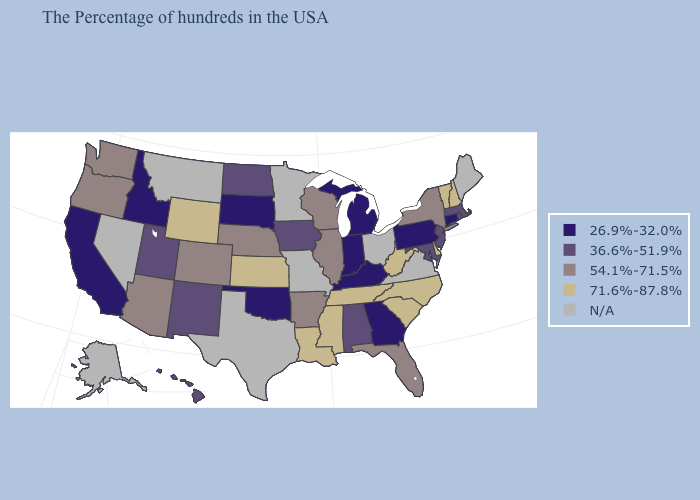What is the highest value in the MidWest ?
Give a very brief answer. 71.6%-87.8%. Which states hav the highest value in the West?
Short answer required. Wyoming. Among the states that border Georgia , which have the highest value?
Answer briefly. North Carolina, South Carolina, Tennessee. What is the lowest value in the USA?
Be succinct. 26.9%-32.0%. Which states have the lowest value in the MidWest?
Short answer required. Michigan, Indiana, South Dakota. Name the states that have a value in the range 54.1%-71.5%?
Write a very short answer. New York, Florida, Wisconsin, Illinois, Arkansas, Nebraska, Colorado, Arizona, Washington, Oregon. Name the states that have a value in the range 26.9%-32.0%?
Keep it brief. Connecticut, Pennsylvania, Georgia, Michigan, Kentucky, Indiana, Oklahoma, South Dakota, Idaho, California. Name the states that have a value in the range 26.9%-32.0%?
Be succinct. Connecticut, Pennsylvania, Georgia, Michigan, Kentucky, Indiana, Oklahoma, South Dakota, Idaho, California. Which states have the lowest value in the USA?
Short answer required. Connecticut, Pennsylvania, Georgia, Michigan, Kentucky, Indiana, Oklahoma, South Dakota, Idaho, California. What is the highest value in the MidWest ?
Quick response, please. 71.6%-87.8%. Does Louisiana have the highest value in the South?
Concise answer only. Yes. Which states have the lowest value in the MidWest?
Keep it brief. Michigan, Indiana, South Dakota. Among the states that border Maryland , which have the lowest value?
Be succinct. Pennsylvania. Name the states that have a value in the range 71.6%-87.8%?
Quick response, please. New Hampshire, Vermont, Delaware, North Carolina, South Carolina, West Virginia, Tennessee, Mississippi, Louisiana, Kansas, Wyoming. 